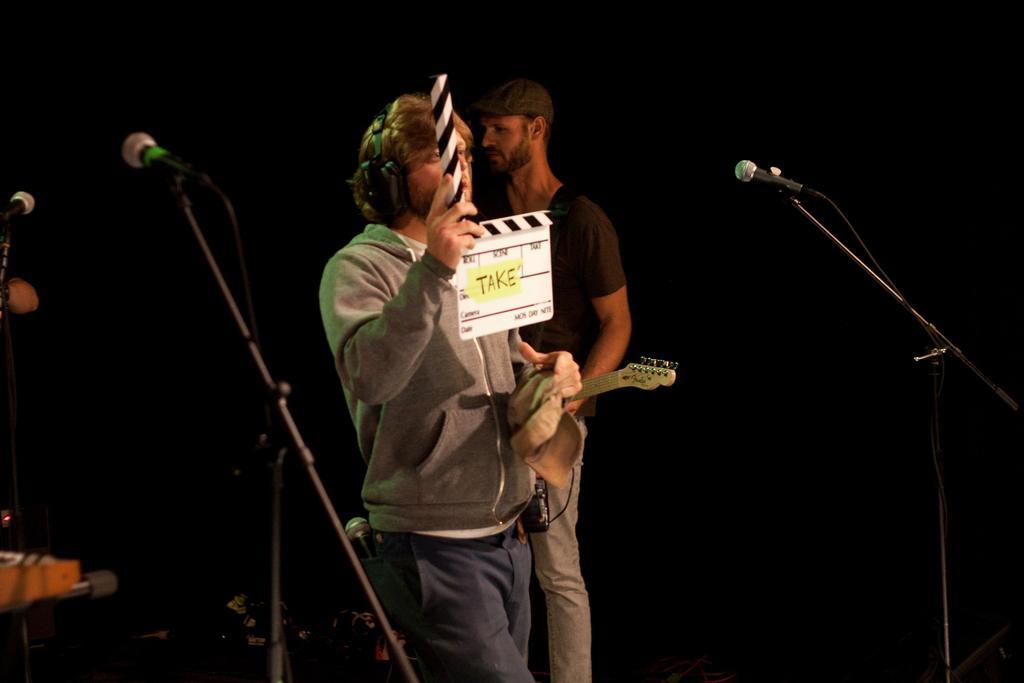Describe this image in one or two sentences. In this picture we can see that two person on the stage, Man wearing white hoodie and blue pant is standing and holding the white color clapper board in his hand and beside a boy wearing black t- shirt is holding a guitar, Beside on the right side microphone stand and on the left a piano with some musical instruments and a microphone stand. 